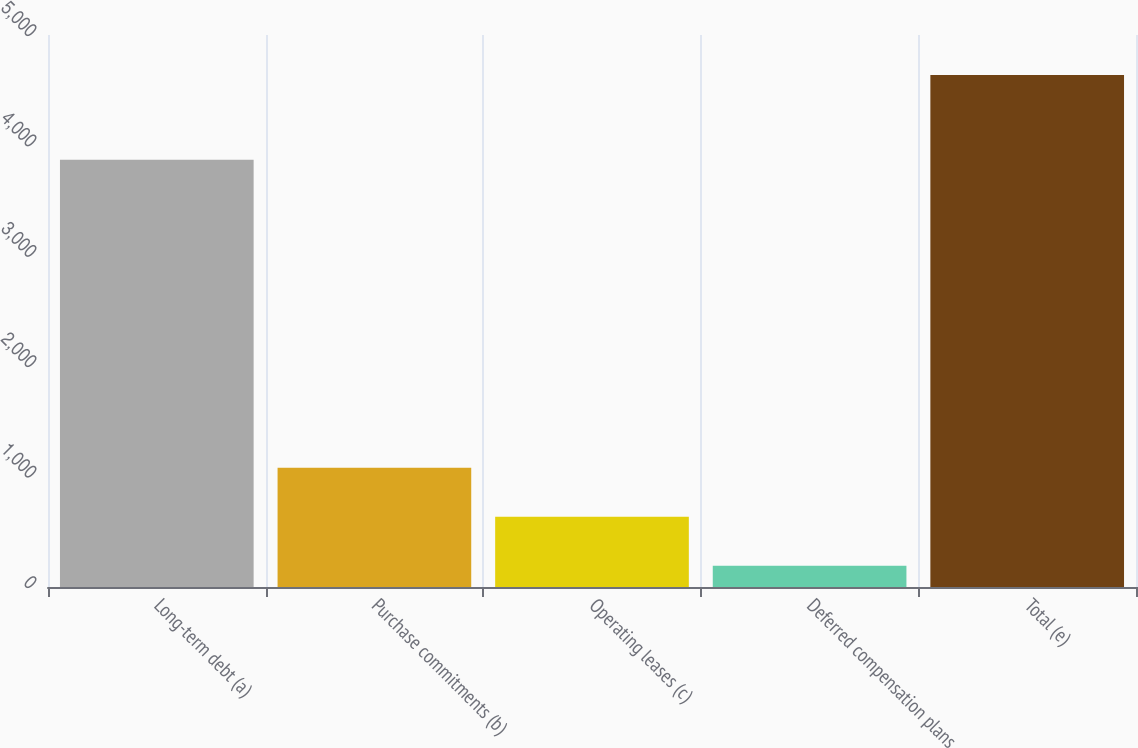<chart> <loc_0><loc_0><loc_500><loc_500><bar_chart><fcel>Long-term debt (a)<fcel>Purchase commitments (b)<fcel>Operating leases (c)<fcel>Deferred compensation plans<fcel>Total (e)<nl><fcel>3869<fcel>1081<fcel>636.5<fcel>192<fcel>4637<nl></chart> 